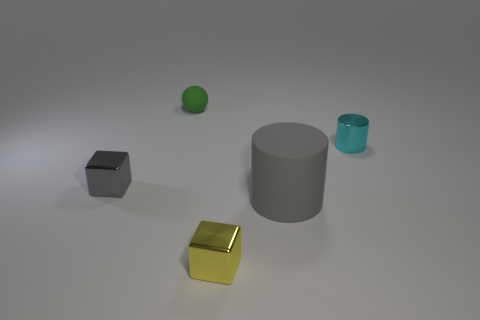There is a big thing; is its color the same as the cube that is behind the large cylinder?
Offer a terse response. Yes. How many tiny metal objects have the same color as the large cylinder?
Provide a short and direct response. 1. What number of other cyan cylinders have the same size as the rubber cylinder?
Your answer should be very brief. 0. What number of gray things have the same shape as the small cyan shiny thing?
Offer a very short reply. 1. Is the number of small cyan shiny objects that are left of the big cylinder the same as the number of large blue metal cylinders?
Offer a very short reply. Yes. Is there any other thing that is the same size as the gray rubber thing?
Ensure brevity in your answer.  No. There is a rubber thing that is the same size as the gray shiny block; what is its shape?
Keep it short and to the point. Sphere. Is there a gray object that has the same shape as the small yellow metallic object?
Make the answer very short. Yes. There is a small thing that is on the left side of the matte thing that is behind the big matte cylinder; are there any shiny cubes that are in front of it?
Ensure brevity in your answer.  Yes. Are there more cylinders in front of the small gray metal block than large gray cylinders that are left of the tiny yellow object?
Your response must be concise. Yes. 